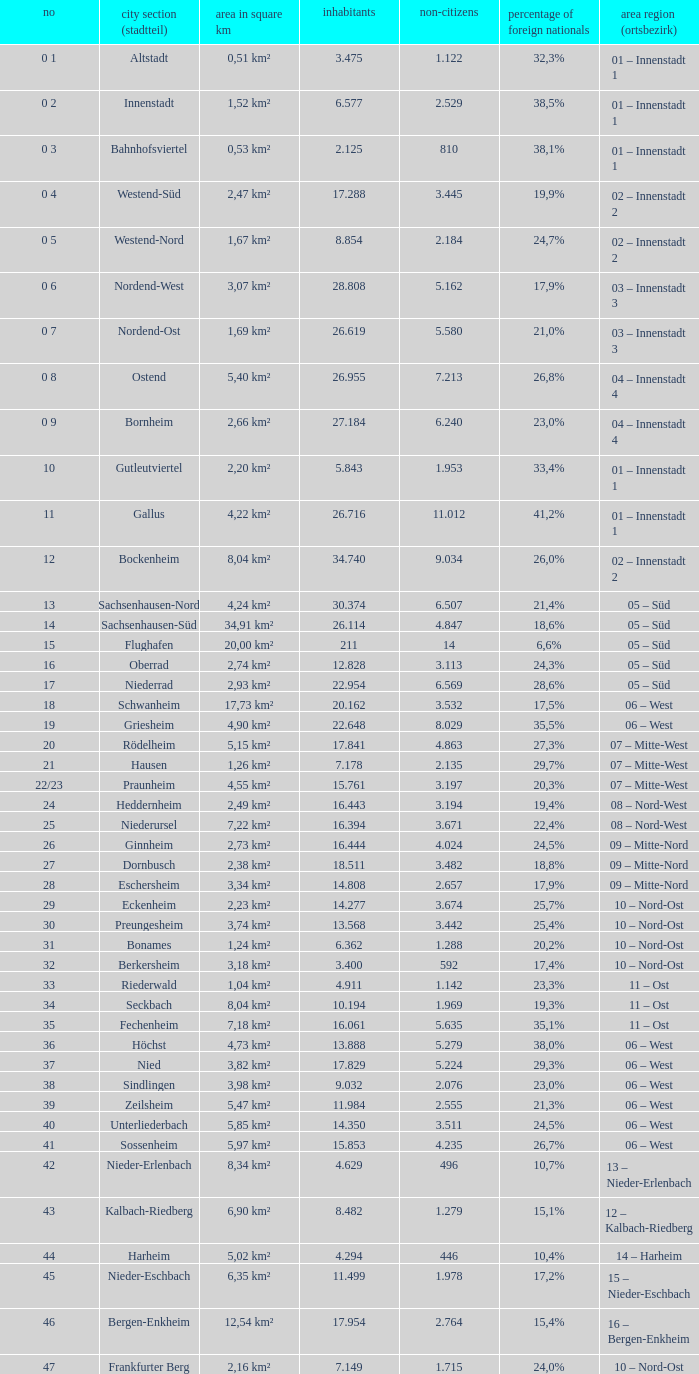What is the city where the number is 47? Frankfurter Berg. 